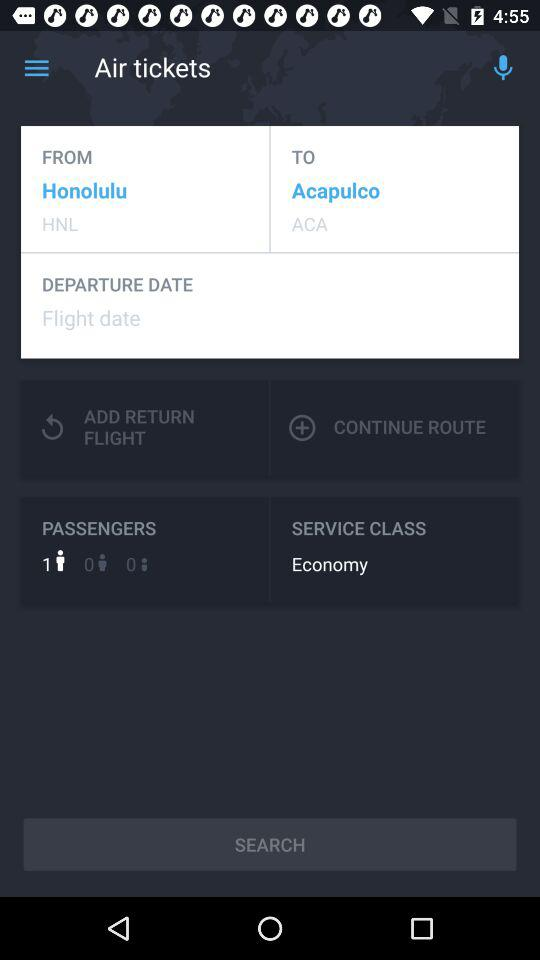What is the arrival location? The arrival location is Acapulco. 